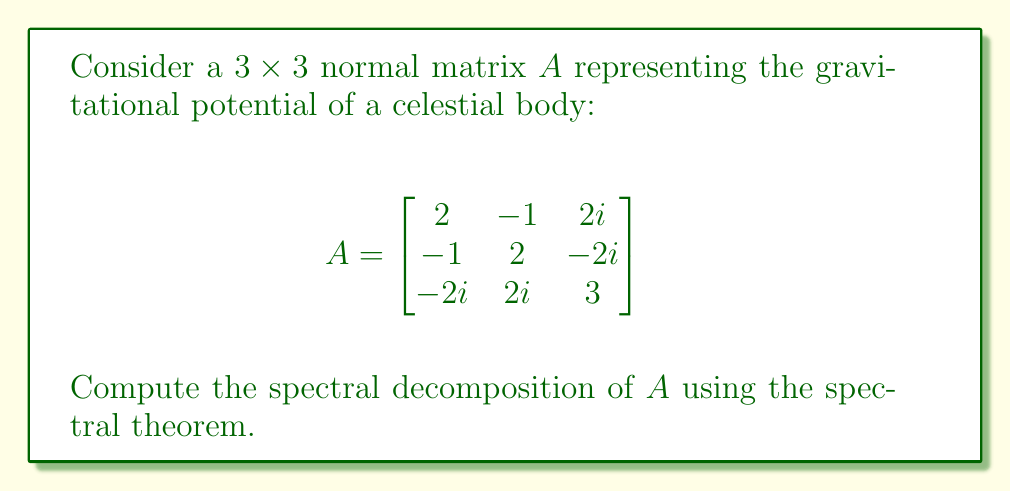Teach me how to tackle this problem. To find the spectral decomposition of the normal matrix $A$, we follow these steps:

1) First, we need to find the eigenvalues of $A$. The characteristic equation is:

   $$\det(A - \lambda I) = \begin{vmatrix}
   2-\lambda & -1 & 2i \\
   -1 & 2-\lambda & -2i \\
   -2i & 2i & 3-\lambda
   \end{vmatrix} = 0$$

2) Expanding this determinant:

   $$(2-\lambda)(2-\lambda)(3-\lambda) + (-1)(-2i)(2i) + (2i)(-1)(2i) - (2-\lambda)(2i)^2 - (3-\lambda)(-1)^2 - (-2i)(-1)(2i) = 0$$

3) Simplifying:

   $$\lambda^3 - 7\lambda^2 + 16\lambda - 12 = 0$$

4) The roots of this equation are the eigenvalues: $\lambda_1 = 1$, $\lambda_2 = 2$, $\lambda_3 = 4$

5) Now, we find the eigenvectors for each eigenvalue:

   For $\lambda_1 = 1$: $v_1 = \frac{1}{\sqrt{2}}[1, -1, 0]^T$
   For $\lambda_2 = 2$: $v_2 = \frac{1}{\sqrt{6}}[1, 1, -2]^T$
   For $\lambda_3 = 4$: $v_3 = \frac{1}{\sqrt{3}}[1, 1, 1]^T$

6) The spectral decomposition is given by $A = UDU^*$, where:

   $$U = [v_1 \; v_2 \; v_3] = \begin{bmatrix}
   \frac{1}{\sqrt{2}} & \frac{1}{\sqrt{6}} & \frac{1}{\sqrt{3}} \\
   -\frac{1}{\sqrt{2}} & \frac{1}{\sqrt{6}} & \frac{1}{\sqrt{3}} \\
   0 & -\frac{2}{\sqrt{6}} & \frac{1}{\sqrt{3}}
   \end{bmatrix}$$

   $$D = \begin{bmatrix}
   1 & 0 & 0 \\
   0 & 2 & 0 \\
   0 & 0 & 4
   \end{bmatrix}$$

7) $U^*$ is the conjugate transpose of $U$.

Therefore, the spectral decomposition of $A$ is $A = UDU^*$.
Answer: $A = UDU^*$, where $U = [\frac{1}{\sqrt{2}}, \frac{1}{\sqrt{6}}, \frac{1}{\sqrt{3}}; -\frac{1}{\sqrt{2}}, \frac{1}{\sqrt{6}}, \frac{1}{\sqrt{3}}; 0, -\frac{2}{\sqrt{6}}, \frac{1}{\sqrt{3}}]$ and $D = \text{diag}(1, 2, 4)$ 